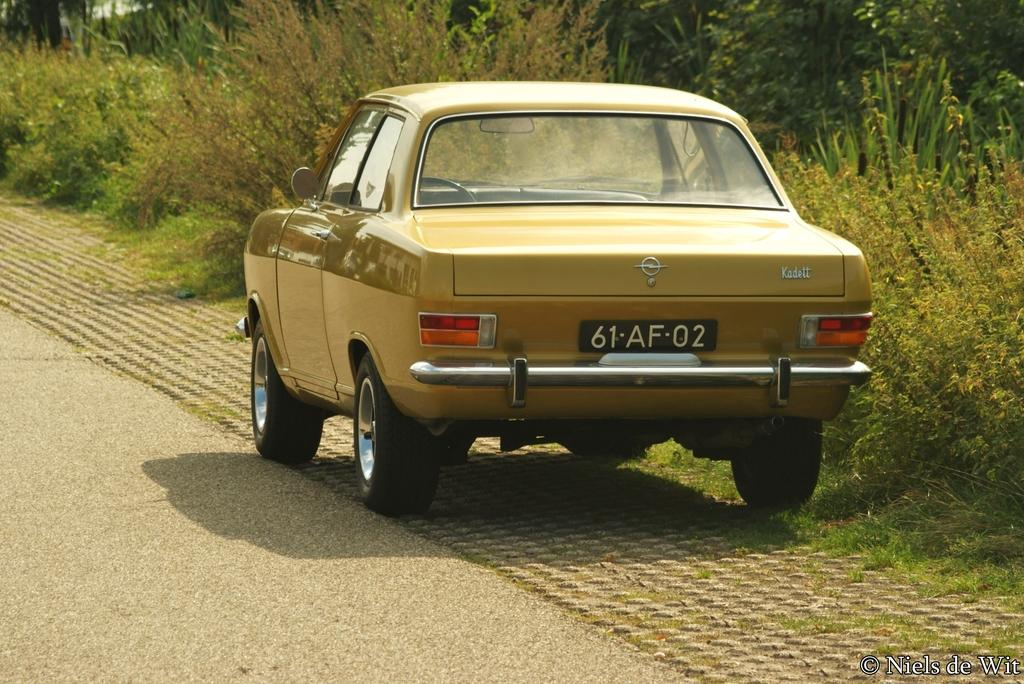What is the main subject of the image? There is a vehicle on the road in the image. What can be seen in the background behind the vehicle? There are trees visible behind the vehicle. Is there any text or logo overlaid on the image? Yes, the image has a watermark. What type of flag is being sold at the market in the image? There is no market or flag present in the image; it features a vehicle on the road with trees in the background and a watermark. What brand of toothpaste is advertised on the vehicle in the image? There is no toothpaste or advertisement present on the vehicle in the image; it is simply a vehicle on the road with trees in the background and a watermark. 